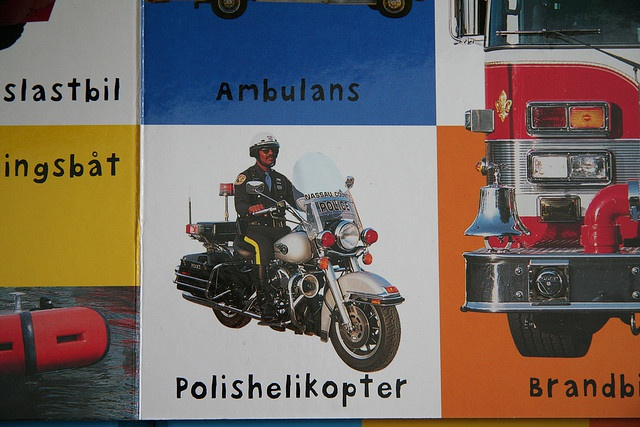Describe the objects in this image and their specific colors. I can see truck in black, brown, darkgray, and gray tones, motorcycle in black, darkgray, gray, and maroon tones, and people in black, gray, darkgray, and maroon tones in this image. 